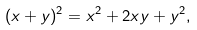<formula> <loc_0><loc_0><loc_500><loc_500>( x + y ) ^ { 2 } = x ^ { 2 } + 2 x y + y ^ { 2 } ,</formula> 